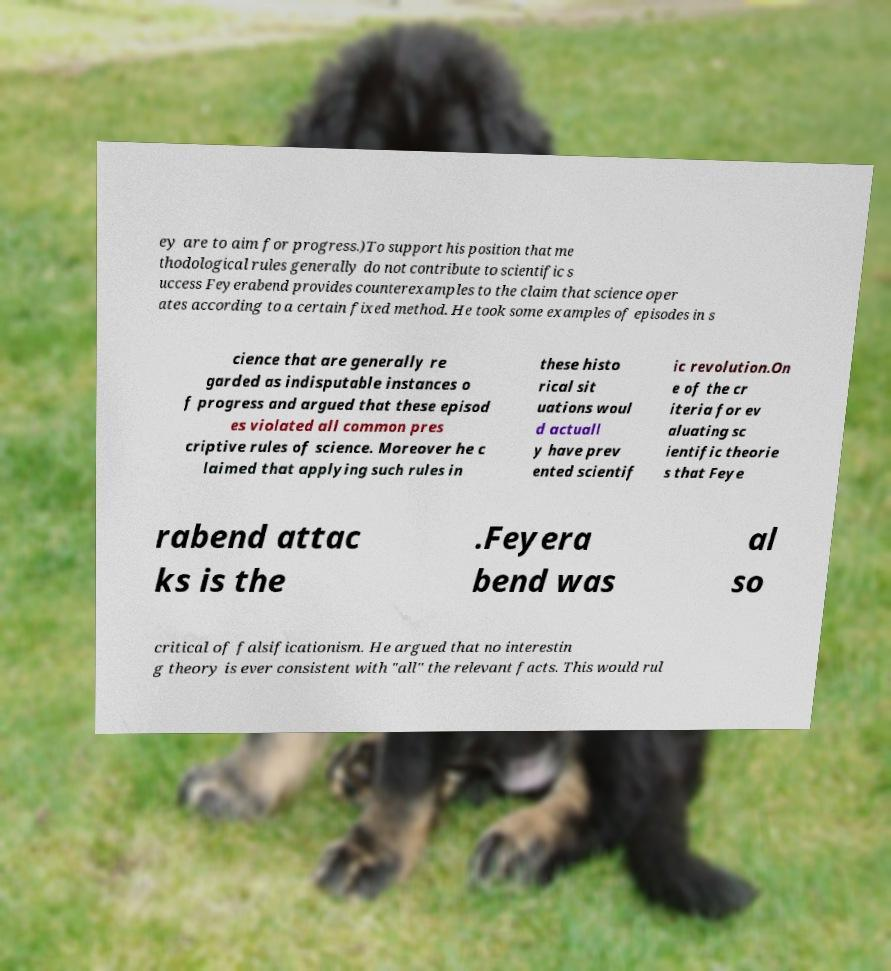Could you extract and type out the text from this image? ey are to aim for progress.)To support his position that me thodological rules generally do not contribute to scientific s uccess Feyerabend provides counterexamples to the claim that science oper ates according to a certain fixed method. He took some examples of episodes in s cience that are generally re garded as indisputable instances o f progress and argued that these episod es violated all common pres criptive rules of science. Moreover he c laimed that applying such rules in these histo rical sit uations woul d actuall y have prev ented scientif ic revolution.On e of the cr iteria for ev aluating sc ientific theorie s that Feye rabend attac ks is the .Feyera bend was al so critical of falsificationism. He argued that no interestin g theory is ever consistent with "all" the relevant facts. This would rul 